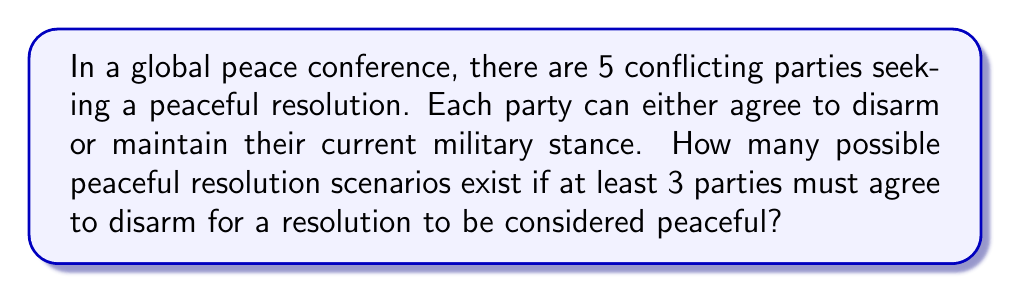Provide a solution to this math problem. Let's approach this step-by-step:

1) We have 5 parties, and each party has 2 choices: disarm or not disarm.

2) We need to find the number of scenarios where at least 3 parties disarm.

3) We can use the concept of combinations to solve this:

   a) Scenarios with exactly 3 parties disarming:
      $${5 \choose 3} = \frac{5!}{3!(5-3)!} = \frac{5 \cdot 4 \cdot 3}{3 \cdot 2 \cdot 1} = 10$$

   b) Scenarios with exactly 4 parties disarming:
      $${5 \choose 4} = \frac{5!}{4!(5-4)!} = \frac{5}{1} = 5$$

   c) Scenario with all 5 parties disarming:
      $${5 \choose 5} = 1$$

4) The total number of peaceful resolution scenarios is the sum of all these possibilities:

   $$10 + 5 + 1 = 16$$

This result aligns with the principle of nonviolent conflict resolution, showing that there are multiple paths to peace even in complex multi-party conflicts.
Answer: 16 